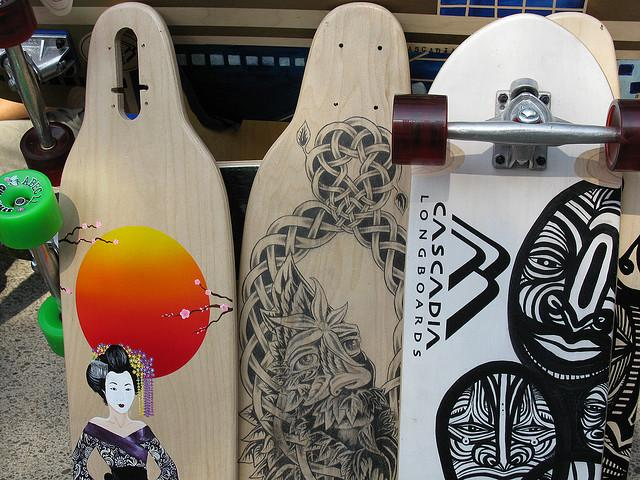This board is used for what sport? skateboarding 